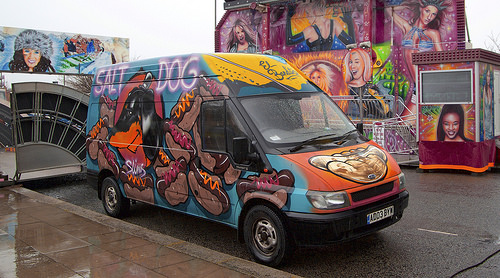<image>
Is there a colored van in front of the amusement ride? Yes. The colored van is positioned in front of the amusement ride, appearing closer to the camera viewpoint. 